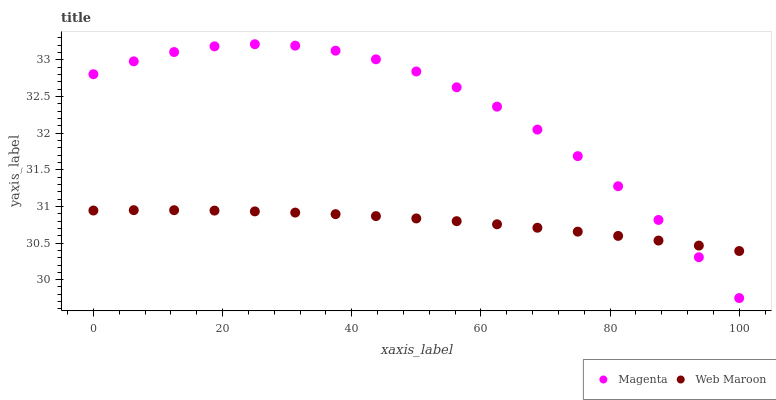Does Web Maroon have the minimum area under the curve?
Answer yes or no. Yes. Does Magenta have the maximum area under the curve?
Answer yes or no. Yes. Does Web Maroon have the maximum area under the curve?
Answer yes or no. No. Is Web Maroon the smoothest?
Answer yes or no. Yes. Is Magenta the roughest?
Answer yes or no. Yes. Is Web Maroon the roughest?
Answer yes or no. No. Does Magenta have the lowest value?
Answer yes or no. Yes. Does Web Maroon have the lowest value?
Answer yes or no. No. Does Magenta have the highest value?
Answer yes or no. Yes. Does Web Maroon have the highest value?
Answer yes or no. No. Does Web Maroon intersect Magenta?
Answer yes or no. Yes. Is Web Maroon less than Magenta?
Answer yes or no. No. Is Web Maroon greater than Magenta?
Answer yes or no. No. 